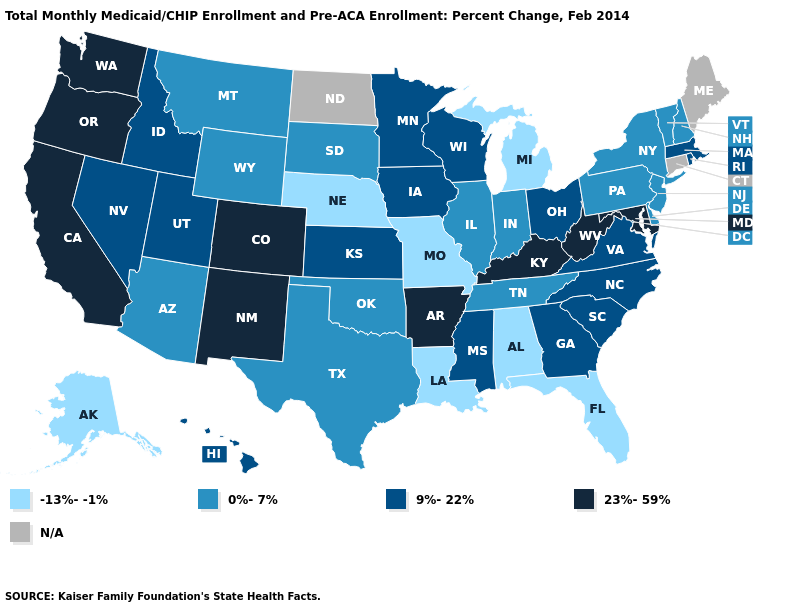Among the states that border New York , which have the lowest value?
Answer briefly. New Jersey, Pennsylvania, Vermont. Name the states that have a value in the range 9%-22%?
Write a very short answer. Georgia, Hawaii, Idaho, Iowa, Kansas, Massachusetts, Minnesota, Mississippi, Nevada, North Carolina, Ohio, Rhode Island, South Carolina, Utah, Virginia, Wisconsin. Which states have the lowest value in the Northeast?
Write a very short answer. New Hampshire, New Jersey, New York, Pennsylvania, Vermont. What is the highest value in states that border Maryland?
Short answer required. 23%-59%. Among the states that border Ohio , does Indiana have the lowest value?
Short answer required. No. Among the states that border Massachusetts , which have the lowest value?
Short answer required. New Hampshire, New York, Vermont. What is the value of Oklahoma?
Quick response, please. 0%-7%. Among the states that border Rhode Island , which have the lowest value?
Keep it brief. Massachusetts. What is the lowest value in the USA?
Quick response, please. -13%--1%. What is the value of New Hampshire?
Give a very brief answer. 0%-7%. Does Nevada have the highest value in the West?
Answer briefly. No. Name the states that have a value in the range 0%-7%?
Short answer required. Arizona, Delaware, Illinois, Indiana, Montana, New Hampshire, New Jersey, New York, Oklahoma, Pennsylvania, South Dakota, Tennessee, Texas, Vermont, Wyoming. Among the states that border Washington , which have the highest value?
Be succinct. Oregon. 